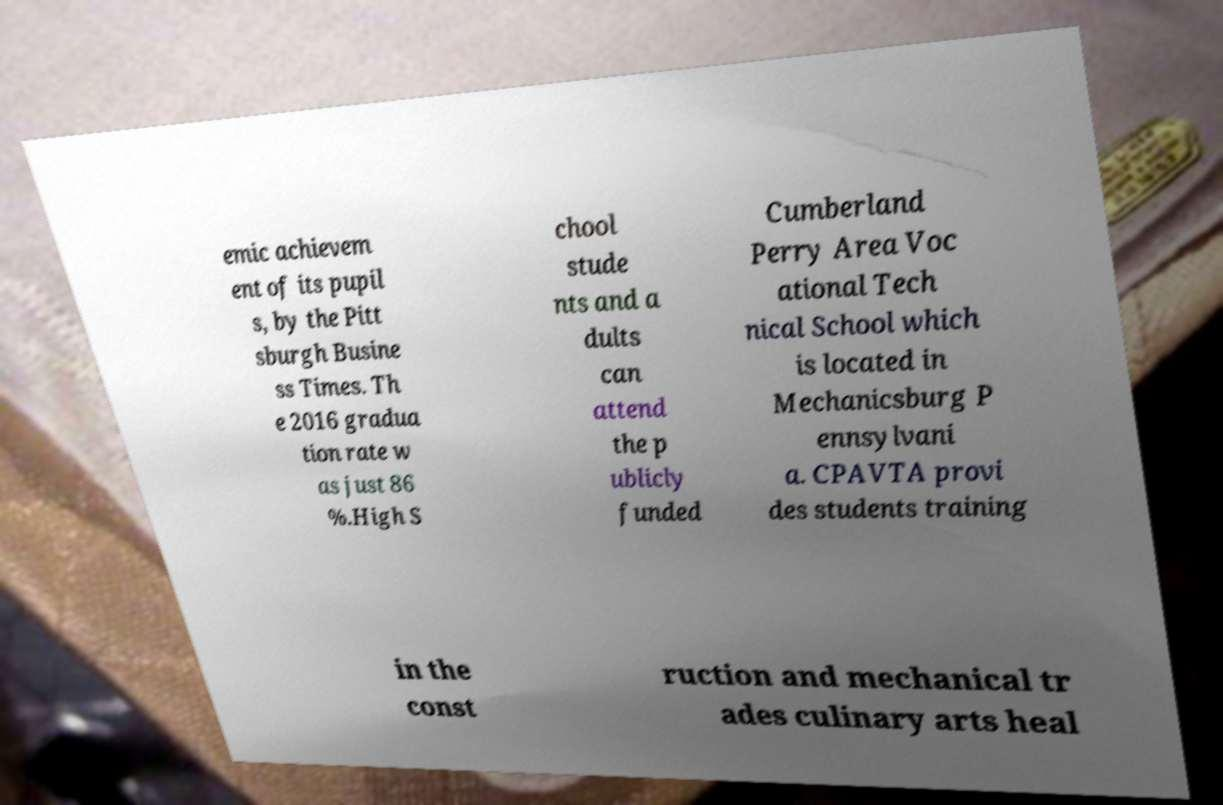Can you read and provide the text displayed in the image?This photo seems to have some interesting text. Can you extract and type it out for me? emic achievem ent of its pupil s, by the Pitt sburgh Busine ss Times. Th e 2016 gradua tion rate w as just 86 %.High S chool stude nts and a dults can attend the p ublicly funded Cumberland Perry Area Voc ational Tech nical School which is located in Mechanicsburg P ennsylvani a. CPAVTA provi des students training in the const ruction and mechanical tr ades culinary arts heal 